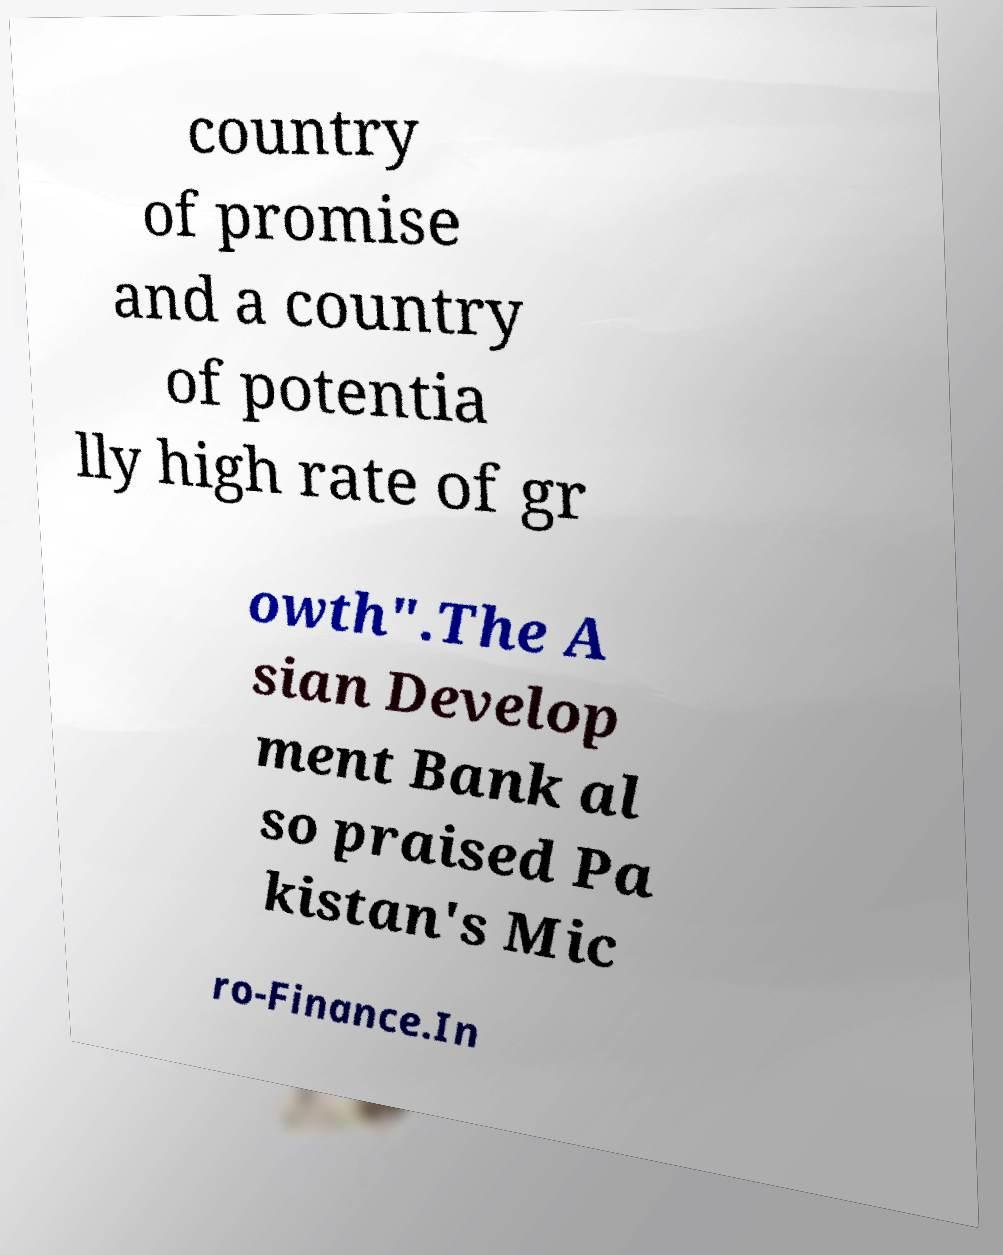Please read and relay the text visible in this image. What does it say? country of promise and a country of potentia lly high rate of gr owth".The A sian Develop ment Bank al so praised Pa kistan's Mic ro-Finance.In 